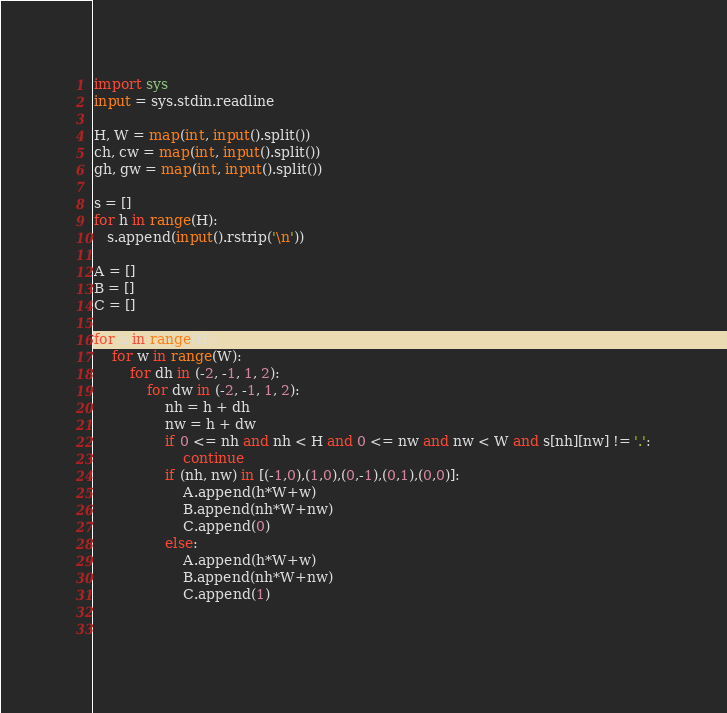Convert code to text. <code><loc_0><loc_0><loc_500><loc_500><_Python_>import sys
input = sys.stdin.readline

H, W = map(int, input().split())
ch, cw = map(int, input().split())
gh, gw = map(int, input().split())

s = []
for h in range(H):
   s.append(input().rstrip('\n'))

A = []
B = []
C = []

for h in range(H):
    for w in range(W):
        for dh in (-2, -1, 1, 2):
            for dw in (-2, -1, 1, 2):
                nh = h + dh
                nw = h + dw
                if 0 <= nh and nh < H and 0 <= nw and nw < W and s[nh][nw] != '.':
                    continue
                if (nh, nw) in [(-1,0),(1,0),(0,-1),(0,1),(0,0)]:
                    A.append(h*W+w)
                    B.append(nh*W+nw)
                    C.append(0)
                else:
                    A.append(h*W+w)
                    B.append(nh*W+nw)
                    C.append(1)

 
</code> 